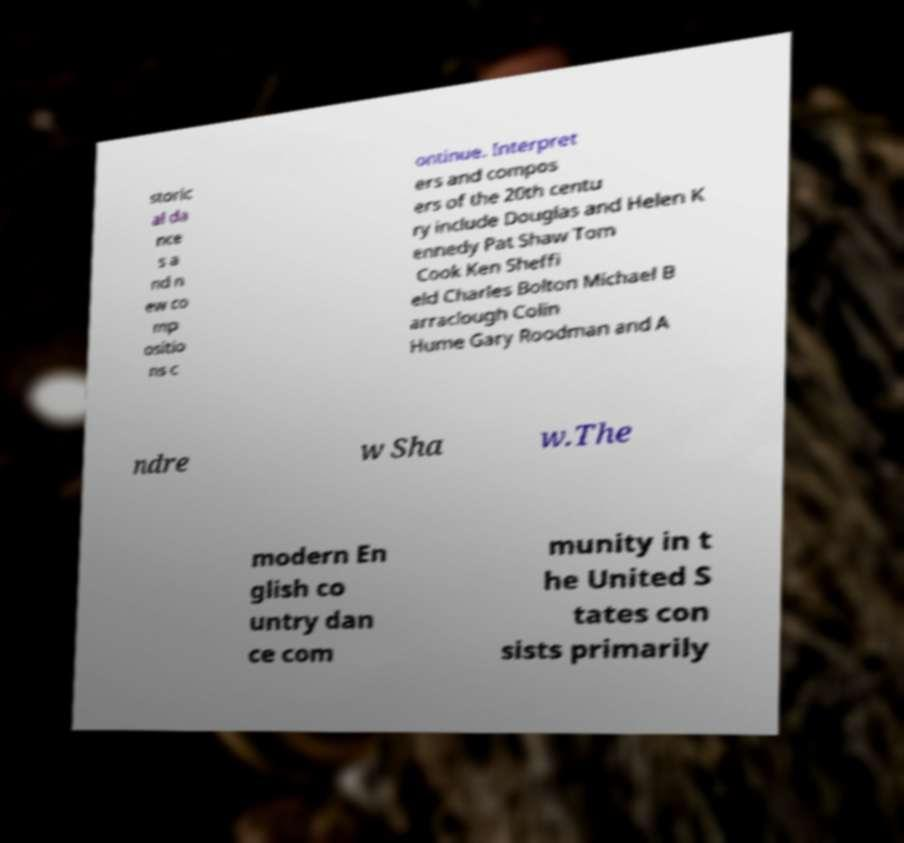I need the written content from this picture converted into text. Can you do that? storic al da nce s a nd n ew co mp ositio ns c ontinue. Interpret ers and compos ers of the 20th centu ry include Douglas and Helen K ennedy Pat Shaw Tom Cook Ken Sheffi eld Charles Bolton Michael B arraclough Colin Hume Gary Roodman and A ndre w Sha w.The modern En glish co untry dan ce com munity in t he United S tates con sists primarily 